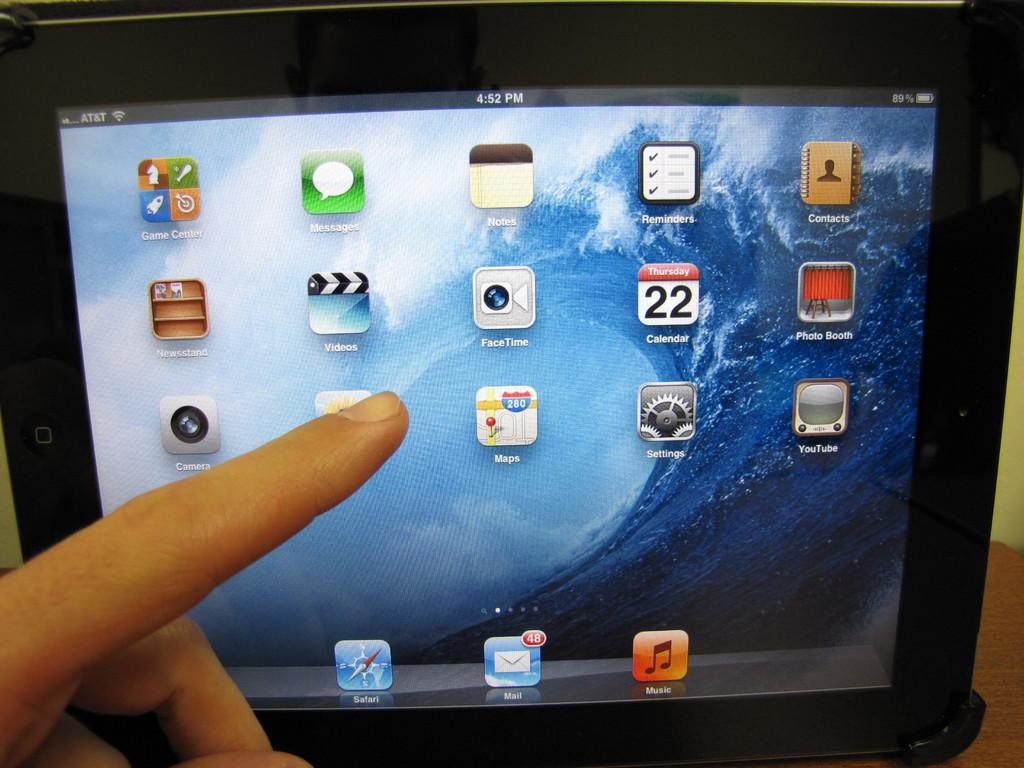What is: What can be seen in the image? There is a person's hand in the image. What is the hand doing in the image? The hand is pointing to a display screen. What type of blade is being used by the person in the image? There is no blade present in the image; it only shows a person's hand pointing to a display screen. 